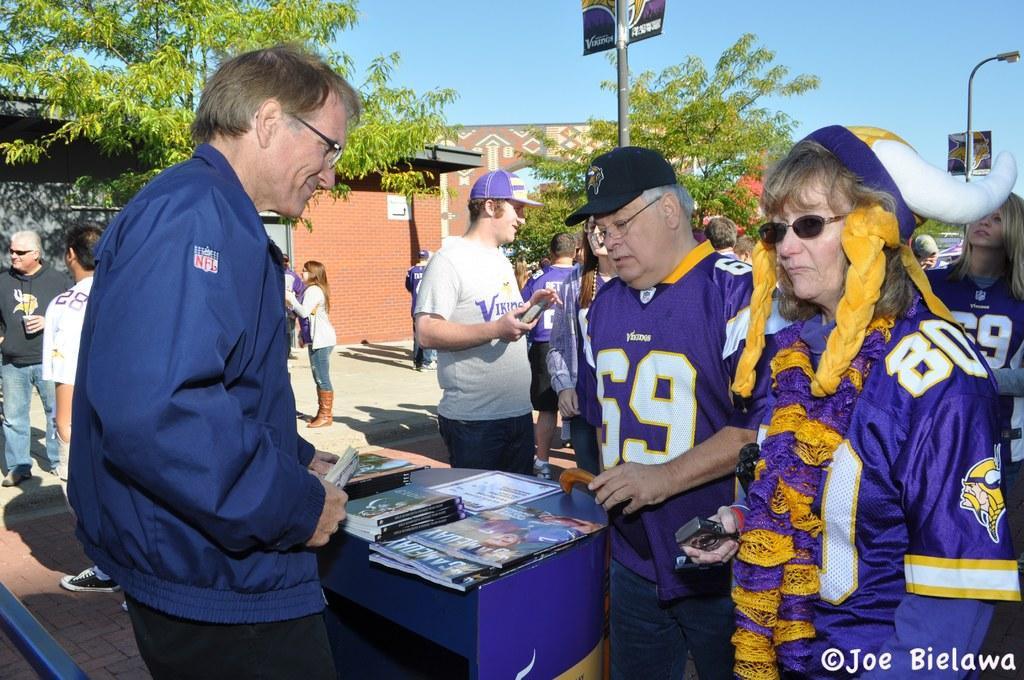Provide a one-sentence caption for the provided image. A game day celebration with an older couple in Vicking jerseys numbered 69 and 80. 